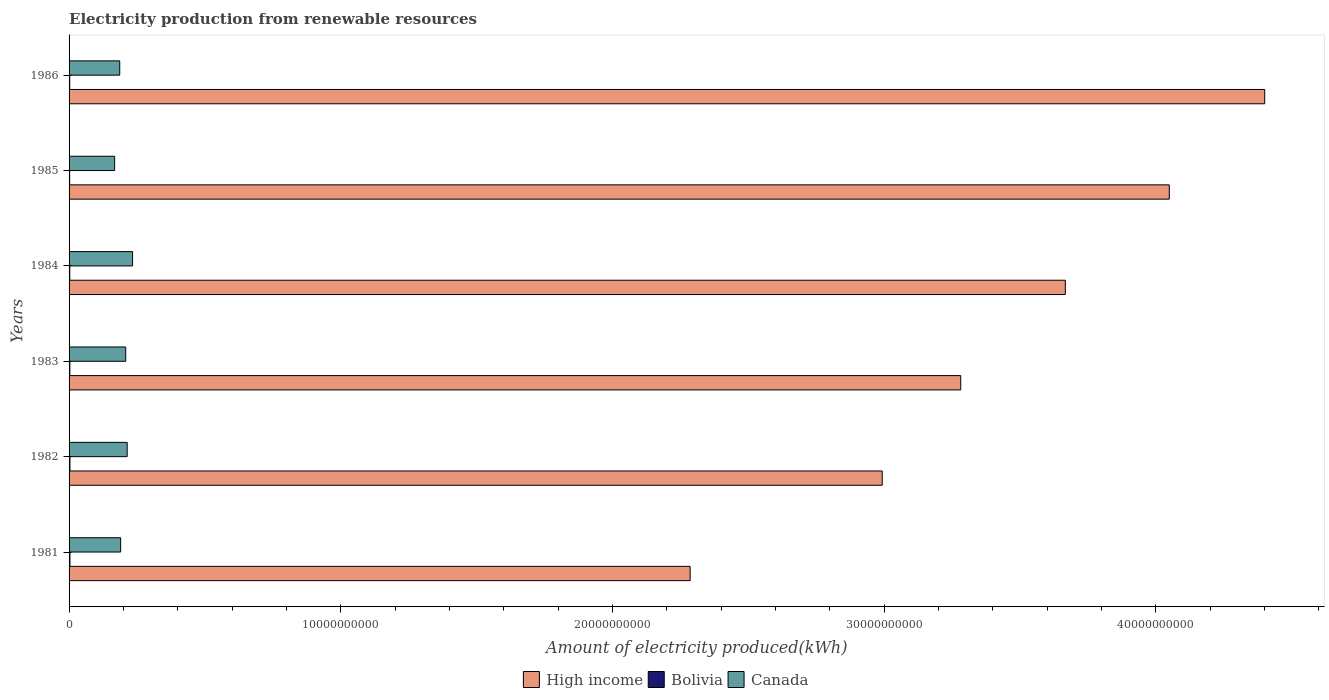How many bars are there on the 6th tick from the top?
Your response must be concise. 3. How many bars are there on the 1st tick from the bottom?
Provide a short and direct response. 3. What is the label of the 6th group of bars from the top?
Provide a succinct answer. 1981. In how many cases, is the number of bars for a given year not equal to the number of legend labels?
Ensure brevity in your answer.  0. What is the amount of electricity produced in Bolivia in 1983?
Your answer should be compact. 2.90e+07. Across all years, what is the maximum amount of electricity produced in Bolivia?
Provide a short and direct response. 3.20e+07. Across all years, what is the minimum amount of electricity produced in Canada?
Make the answer very short. 1.68e+09. What is the total amount of electricity produced in High income in the graph?
Make the answer very short. 2.07e+11. What is the difference between the amount of electricity produced in High income in 1981 and that in 1983?
Your response must be concise. -9.96e+09. What is the difference between the amount of electricity produced in Canada in 1985 and the amount of electricity produced in Bolivia in 1986?
Provide a succinct answer. 1.65e+09. What is the average amount of electricity produced in Bolivia per year?
Provide a short and direct response. 2.75e+07. In the year 1982, what is the difference between the amount of electricity produced in Bolivia and amount of electricity produced in High income?
Your response must be concise. -2.99e+1. What is the ratio of the amount of electricity produced in High income in 1981 to that in 1986?
Give a very brief answer. 0.52. Is the difference between the amount of electricity produced in Bolivia in 1982 and 1986 greater than the difference between the amount of electricity produced in High income in 1982 and 1986?
Give a very brief answer. Yes. What is the difference between the highest and the second highest amount of electricity produced in Canada?
Your response must be concise. 1.98e+08. What is the difference between the highest and the lowest amount of electricity produced in Canada?
Ensure brevity in your answer.  6.60e+08. What does the 2nd bar from the top in 1986 represents?
Provide a succinct answer. Bolivia. What does the 2nd bar from the bottom in 1982 represents?
Provide a short and direct response. Bolivia. How many bars are there?
Your answer should be very brief. 18. What is the difference between two consecutive major ticks on the X-axis?
Your answer should be compact. 1.00e+1. How are the legend labels stacked?
Keep it short and to the point. Horizontal. What is the title of the graph?
Offer a very short reply. Electricity production from renewable resources. What is the label or title of the X-axis?
Your answer should be very brief. Amount of electricity produced(kWh). What is the label or title of the Y-axis?
Keep it short and to the point. Years. What is the Amount of electricity produced(kWh) in High income in 1981?
Your response must be concise. 2.29e+1. What is the Amount of electricity produced(kWh) of Bolivia in 1981?
Make the answer very short. 3.20e+07. What is the Amount of electricity produced(kWh) in Canada in 1981?
Provide a short and direct response. 1.90e+09. What is the Amount of electricity produced(kWh) in High income in 1982?
Make the answer very short. 2.99e+1. What is the Amount of electricity produced(kWh) in Bolivia in 1982?
Your response must be concise. 3.20e+07. What is the Amount of electricity produced(kWh) of Canada in 1982?
Ensure brevity in your answer.  2.14e+09. What is the Amount of electricity produced(kWh) of High income in 1983?
Your answer should be very brief. 3.28e+1. What is the Amount of electricity produced(kWh) in Bolivia in 1983?
Offer a terse response. 2.90e+07. What is the Amount of electricity produced(kWh) of Canada in 1983?
Your answer should be compact. 2.08e+09. What is the Amount of electricity produced(kWh) of High income in 1984?
Ensure brevity in your answer.  3.67e+1. What is the Amount of electricity produced(kWh) of Bolivia in 1984?
Your answer should be very brief. 2.60e+07. What is the Amount of electricity produced(kWh) in Canada in 1984?
Your response must be concise. 2.34e+09. What is the Amount of electricity produced(kWh) of High income in 1985?
Offer a terse response. 4.05e+1. What is the Amount of electricity produced(kWh) in Bolivia in 1985?
Your answer should be very brief. 2.20e+07. What is the Amount of electricity produced(kWh) of Canada in 1985?
Ensure brevity in your answer.  1.68e+09. What is the Amount of electricity produced(kWh) of High income in 1986?
Give a very brief answer. 4.40e+1. What is the Amount of electricity produced(kWh) of Bolivia in 1986?
Keep it short and to the point. 2.40e+07. What is the Amount of electricity produced(kWh) of Canada in 1986?
Your response must be concise. 1.86e+09. Across all years, what is the maximum Amount of electricity produced(kWh) of High income?
Ensure brevity in your answer.  4.40e+1. Across all years, what is the maximum Amount of electricity produced(kWh) of Bolivia?
Your response must be concise. 3.20e+07. Across all years, what is the maximum Amount of electricity produced(kWh) in Canada?
Offer a very short reply. 2.34e+09. Across all years, what is the minimum Amount of electricity produced(kWh) of High income?
Offer a very short reply. 2.29e+1. Across all years, what is the minimum Amount of electricity produced(kWh) of Bolivia?
Ensure brevity in your answer.  2.20e+07. Across all years, what is the minimum Amount of electricity produced(kWh) of Canada?
Make the answer very short. 1.68e+09. What is the total Amount of electricity produced(kWh) in High income in the graph?
Your answer should be very brief. 2.07e+11. What is the total Amount of electricity produced(kWh) of Bolivia in the graph?
Your answer should be very brief. 1.65e+08. What is the total Amount of electricity produced(kWh) of Canada in the graph?
Provide a succinct answer. 1.20e+1. What is the difference between the Amount of electricity produced(kWh) of High income in 1981 and that in 1982?
Offer a very short reply. -7.07e+09. What is the difference between the Amount of electricity produced(kWh) of Bolivia in 1981 and that in 1982?
Offer a very short reply. 0. What is the difference between the Amount of electricity produced(kWh) of Canada in 1981 and that in 1982?
Make the answer very short. -2.41e+08. What is the difference between the Amount of electricity produced(kWh) in High income in 1981 and that in 1983?
Provide a succinct answer. -9.96e+09. What is the difference between the Amount of electricity produced(kWh) in Canada in 1981 and that in 1983?
Your answer should be very brief. -1.87e+08. What is the difference between the Amount of electricity produced(kWh) of High income in 1981 and that in 1984?
Provide a succinct answer. -1.38e+1. What is the difference between the Amount of electricity produced(kWh) of Canada in 1981 and that in 1984?
Ensure brevity in your answer.  -4.39e+08. What is the difference between the Amount of electricity produced(kWh) in High income in 1981 and that in 1985?
Offer a very short reply. -1.76e+1. What is the difference between the Amount of electricity produced(kWh) in Canada in 1981 and that in 1985?
Provide a short and direct response. 2.21e+08. What is the difference between the Amount of electricity produced(kWh) of High income in 1981 and that in 1986?
Offer a very short reply. -2.11e+1. What is the difference between the Amount of electricity produced(kWh) of Bolivia in 1981 and that in 1986?
Provide a succinct answer. 8.00e+06. What is the difference between the Amount of electricity produced(kWh) of Canada in 1981 and that in 1986?
Provide a succinct answer. 3.30e+07. What is the difference between the Amount of electricity produced(kWh) in High income in 1982 and that in 1983?
Your answer should be very brief. -2.89e+09. What is the difference between the Amount of electricity produced(kWh) of Canada in 1982 and that in 1983?
Your response must be concise. 5.40e+07. What is the difference between the Amount of electricity produced(kWh) in High income in 1982 and that in 1984?
Offer a very short reply. -6.74e+09. What is the difference between the Amount of electricity produced(kWh) of Bolivia in 1982 and that in 1984?
Your answer should be compact. 6.00e+06. What is the difference between the Amount of electricity produced(kWh) of Canada in 1982 and that in 1984?
Your response must be concise. -1.98e+08. What is the difference between the Amount of electricity produced(kWh) in High income in 1982 and that in 1985?
Your answer should be compact. -1.06e+1. What is the difference between the Amount of electricity produced(kWh) in Canada in 1982 and that in 1985?
Your response must be concise. 4.62e+08. What is the difference between the Amount of electricity produced(kWh) in High income in 1982 and that in 1986?
Your answer should be compact. -1.41e+1. What is the difference between the Amount of electricity produced(kWh) in Bolivia in 1982 and that in 1986?
Give a very brief answer. 8.00e+06. What is the difference between the Amount of electricity produced(kWh) in Canada in 1982 and that in 1986?
Offer a terse response. 2.74e+08. What is the difference between the Amount of electricity produced(kWh) in High income in 1983 and that in 1984?
Offer a very short reply. -3.85e+09. What is the difference between the Amount of electricity produced(kWh) of Bolivia in 1983 and that in 1984?
Keep it short and to the point. 3.00e+06. What is the difference between the Amount of electricity produced(kWh) of Canada in 1983 and that in 1984?
Ensure brevity in your answer.  -2.52e+08. What is the difference between the Amount of electricity produced(kWh) in High income in 1983 and that in 1985?
Your answer should be compact. -7.68e+09. What is the difference between the Amount of electricity produced(kWh) in Bolivia in 1983 and that in 1985?
Your answer should be very brief. 7.00e+06. What is the difference between the Amount of electricity produced(kWh) in Canada in 1983 and that in 1985?
Provide a succinct answer. 4.08e+08. What is the difference between the Amount of electricity produced(kWh) in High income in 1983 and that in 1986?
Your answer should be very brief. -1.12e+1. What is the difference between the Amount of electricity produced(kWh) in Canada in 1983 and that in 1986?
Provide a short and direct response. 2.20e+08. What is the difference between the Amount of electricity produced(kWh) of High income in 1984 and that in 1985?
Provide a short and direct response. -3.83e+09. What is the difference between the Amount of electricity produced(kWh) of Bolivia in 1984 and that in 1985?
Your answer should be very brief. 4.00e+06. What is the difference between the Amount of electricity produced(kWh) of Canada in 1984 and that in 1985?
Your answer should be compact. 6.60e+08. What is the difference between the Amount of electricity produced(kWh) in High income in 1984 and that in 1986?
Make the answer very short. -7.34e+09. What is the difference between the Amount of electricity produced(kWh) of Canada in 1984 and that in 1986?
Give a very brief answer. 4.72e+08. What is the difference between the Amount of electricity produced(kWh) in High income in 1985 and that in 1986?
Provide a succinct answer. -3.51e+09. What is the difference between the Amount of electricity produced(kWh) of Canada in 1985 and that in 1986?
Your response must be concise. -1.88e+08. What is the difference between the Amount of electricity produced(kWh) in High income in 1981 and the Amount of electricity produced(kWh) in Bolivia in 1982?
Make the answer very short. 2.28e+1. What is the difference between the Amount of electricity produced(kWh) in High income in 1981 and the Amount of electricity produced(kWh) in Canada in 1982?
Give a very brief answer. 2.07e+1. What is the difference between the Amount of electricity produced(kWh) of Bolivia in 1981 and the Amount of electricity produced(kWh) of Canada in 1982?
Make the answer very short. -2.11e+09. What is the difference between the Amount of electricity produced(kWh) of High income in 1981 and the Amount of electricity produced(kWh) of Bolivia in 1983?
Provide a succinct answer. 2.28e+1. What is the difference between the Amount of electricity produced(kWh) of High income in 1981 and the Amount of electricity produced(kWh) of Canada in 1983?
Offer a terse response. 2.08e+1. What is the difference between the Amount of electricity produced(kWh) in Bolivia in 1981 and the Amount of electricity produced(kWh) in Canada in 1983?
Keep it short and to the point. -2.05e+09. What is the difference between the Amount of electricity produced(kWh) in High income in 1981 and the Amount of electricity produced(kWh) in Bolivia in 1984?
Your response must be concise. 2.28e+1. What is the difference between the Amount of electricity produced(kWh) in High income in 1981 and the Amount of electricity produced(kWh) in Canada in 1984?
Provide a short and direct response. 2.05e+1. What is the difference between the Amount of electricity produced(kWh) in Bolivia in 1981 and the Amount of electricity produced(kWh) in Canada in 1984?
Give a very brief answer. -2.30e+09. What is the difference between the Amount of electricity produced(kWh) of High income in 1981 and the Amount of electricity produced(kWh) of Bolivia in 1985?
Provide a short and direct response. 2.28e+1. What is the difference between the Amount of electricity produced(kWh) in High income in 1981 and the Amount of electricity produced(kWh) in Canada in 1985?
Give a very brief answer. 2.12e+1. What is the difference between the Amount of electricity produced(kWh) in Bolivia in 1981 and the Amount of electricity produced(kWh) in Canada in 1985?
Keep it short and to the point. -1.64e+09. What is the difference between the Amount of electricity produced(kWh) in High income in 1981 and the Amount of electricity produced(kWh) in Bolivia in 1986?
Provide a short and direct response. 2.28e+1. What is the difference between the Amount of electricity produced(kWh) in High income in 1981 and the Amount of electricity produced(kWh) in Canada in 1986?
Provide a short and direct response. 2.10e+1. What is the difference between the Amount of electricity produced(kWh) of Bolivia in 1981 and the Amount of electricity produced(kWh) of Canada in 1986?
Your answer should be compact. -1.83e+09. What is the difference between the Amount of electricity produced(kWh) in High income in 1982 and the Amount of electricity produced(kWh) in Bolivia in 1983?
Your answer should be compact. 2.99e+1. What is the difference between the Amount of electricity produced(kWh) of High income in 1982 and the Amount of electricity produced(kWh) of Canada in 1983?
Your answer should be compact. 2.78e+1. What is the difference between the Amount of electricity produced(kWh) of Bolivia in 1982 and the Amount of electricity produced(kWh) of Canada in 1983?
Give a very brief answer. -2.05e+09. What is the difference between the Amount of electricity produced(kWh) of High income in 1982 and the Amount of electricity produced(kWh) of Bolivia in 1984?
Provide a succinct answer. 2.99e+1. What is the difference between the Amount of electricity produced(kWh) in High income in 1982 and the Amount of electricity produced(kWh) in Canada in 1984?
Make the answer very short. 2.76e+1. What is the difference between the Amount of electricity produced(kWh) in Bolivia in 1982 and the Amount of electricity produced(kWh) in Canada in 1984?
Your response must be concise. -2.30e+09. What is the difference between the Amount of electricity produced(kWh) of High income in 1982 and the Amount of electricity produced(kWh) of Bolivia in 1985?
Keep it short and to the point. 2.99e+1. What is the difference between the Amount of electricity produced(kWh) of High income in 1982 and the Amount of electricity produced(kWh) of Canada in 1985?
Make the answer very short. 2.83e+1. What is the difference between the Amount of electricity produced(kWh) in Bolivia in 1982 and the Amount of electricity produced(kWh) in Canada in 1985?
Offer a very short reply. -1.64e+09. What is the difference between the Amount of electricity produced(kWh) in High income in 1982 and the Amount of electricity produced(kWh) in Bolivia in 1986?
Keep it short and to the point. 2.99e+1. What is the difference between the Amount of electricity produced(kWh) of High income in 1982 and the Amount of electricity produced(kWh) of Canada in 1986?
Your answer should be compact. 2.81e+1. What is the difference between the Amount of electricity produced(kWh) of Bolivia in 1982 and the Amount of electricity produced(kWh) of Canada in 1986?
Provide a short and direct response. -1.83e+09. What is the difference between the Amount of electricity produced(kWh) of High income in 1983 and the Amount of electricity produced(kWh) of Bolivia in 1984?
Keep it short and to the point. 3.28e+1. What is the difference between the Amount of electricity produced(kWh) in High income in 1983 and the Amount of electricity produced(kWh) in Canada in 1984?
Offer a terse response. 3.05e+1. What is the difference between the Amount of electricity produced(kWh) in Bolivia in 1983 and the Amount of electricity produced(kWh) in Canada in 1984?
Make the answer very short. -2.31e+09. What is the difference between the Amount of electricity produced(kWh) of High income in 1983 and the Amount of electricity produced(kWh) of Bolivia in 1985?
Offer a very short reply. 3.28e+1. What is the difference between the Amount of electricity produced(kWh) in High income in 1983 and the Amount of electricity produced(kWh) in Canada in 1985?
Your response must be concise. 3.11e+1. What is the difference between the Amount of electricity produced(kWh) of Bolivia in 1983 and the Amount of electricity produced(kWh) of Canada in 1985?
Provide a succinct answer. -1.65e+09. What is the difference between the Amount of electricity produced(kWh) of High income in 1983 and the Amount of electricity produced(kWh) of Bolivia in 1986?
Make the answer very short. 3.28e+1. What is the difference between the Amount of electricity produced(kWh) in High income in 1983 and the Amount of electricity produced(kWh) in Canada in 1986?
Your response must be concise. 3.10e+1. What is the difference between the Amount of electricity produced(kWh) in Bolivia in 1983 and the Amount of electricity produced(kWh) in Canada in 1986?
Your answer should be compact. -1.84e+09. What is the difference between the Amount of electricity produced(kWh) of High income in 1984 and the Amount of electricity produced(kWh) of Bolivia in 1985?
Your response must be concise. 3.66e+1. What is the difference between the Amount of electricity produced(kWh) of High income in 1984 and the Amount of electricity produced(kWh) of Canada in 1985?
Your answer should be very brief. 3.50e+1. What is the difference between the Amount of electricity produced(kWh) in Bolivia in 1984 and the Amount of electricity produced(kWh) in Canada in 1985?
Ensure brevity in your answer.  -1.65e+09. What is the difference between the Amount of electricity produced(kWh) of High income in 1984 and the Amount of electricity produced(kWh) of Bolivia in 1986?
Your answer should be very brief. 3.66e+1. What is the difference between the Amount of electricity produced(kWh) of High income in 1984 and the Amount of electricity produced(kWh) of Canada in 1986?
Offer a very short reply. 3.48e+1. What is the difference between the Amount of electricity produced(kWh) in Bolivia in 1984 and the Amount of electricity produced(kWh) in Canada in 1986?
Offer a very short reply. -1.84e+09. What is the difference between the Amount of electricity produced(kWh) of High income in 1985 and the Amount of electricity produced(kWh) of Bolivia in 1986?
Your answer should be compact. 4.05e+1. What is the difference between the Amount of electricity produced(kWh) in High income in 1985 and the Amount of electricity produced(kWh) in Canada in 1986?
Keep it short and to the point. 3.86e+1. What is the difference between the Amount of electricity produced(kWh) in Bolivia in 1985 and the Amount of electricity produced(kWh) in Canada in 1986?
Your answer should be compact. -1.84e+09. What is the average Amount of electricity produced(kWh) in High income per year?
Ensure brevity in your answer.  3.45e+1. What is the average Amount of electricity produced(kWh) of Bolivia per year?
Make the answer very short. 2.75e+07. What is the average Amount of electricity produced(kWh) in Canada per year?
Provide a succinct answer. 2.00e+09. In the year 1981, what is the difference between the Amount of electricity produced(kWh) of High income and Amount of electricity produced(kWh) of Bolivia?
Offer a very short reply. 2.28e+1. In the year 1981, what is the difference between the Amount of electricity produced(kWh) of High income and Amount of electricity produced(kWh) of Canada?
Provide a succinct answer. 2.10e+1. In the year 1981, what is the difference between the Amount of electricity produced(kWh) of Bolivia and Amount of electricity produced(kWh) of Canada?
Keep it short and to the point. -1.87e+09. In the year 1982, what is the difference between the Amount of electricity produced(kWh) in High income and Amount of electricity produced(kWh) in Bolivia?
Provide a succinct answer. 2.99e+1. In the year 1982, what is the difference between the Amount of electricity produced(kWh) in High income and Amount of electricity produced(kWh) in Canada?
Offer a terse response. 2.78e+1. In the year 1982, what is the difference between the Amount of electricity produced(kWh) in Bolivia and Amount of electricity produced(kWh) in Canada?
Give a very brief answer. -2.11e+09. In the year 1983, what is the difference between the Amount of electricity produced(kWh) in High income and Amount of electricity produced(kWh) in Bolivia?
Your answer should be very brief. 3.28e+1. In the year 1983, what is the difference between the Amount of electricity produced(kWh) in High income and Amount of electricity produced(kWh) in Canada?
Ensure brevity in your answer.  3.07e+1. In the year 1983, what is the difference between the Amount of electricity produced(kWh) in Bolivia and Amount of electricity produced(kWh) in Canada?
Your answer should be compact. -2.06e+09. In the year 1984, what is the difference between the Amount of electricity produced(kWh) of High income and Amount of electricity produced(kWh) of Bolivia?
Ensure brevity in your answer.  3.66e+1. In the year 1984, what is the difference between the Amount of electricity produced(kWh) of High income and Amount of electricity produced(kWh) of Canada?
Make the answer very short. 3.43e+1. In the year 1984, what is the difference between the Amount of electricity produced(kWh) of Bolivia and Amount of electricity produced(kWh) of Canada?
Offer a terse response. -2.31e+09. In the year 1985, what is the difference between the Amount of electricity produced(kWh) in High income and Amount of electricity produced(kWh) in Bolivia?
Your response must be concise. 4.05e+1. In the year 1985, what is the difference between the Amount of electricity produced(kWh) of High income and Amount of electricity produced(kWh) of Canada?
Provide a short and direct response. 3.88e+1. In the year 1985, what is the difference between the Amount of electricity produced(kWh) in Bolivia and Amount of electricity produced(kWh) in Canada?
Make the answer very short. -1.66e+09. In the year 1986, what is the difference between the Amount of electricity produced(kWh) in High income and Amount of electricity produced(kWh) in Bolivia?
Provide a short and direct response. 4.40e+1. In the year 1986, what is the difference between the Amount of electricity produced(kWh) of High income and Amount of electricity produced(kWh) of Canada?
Offer a very short reply. 4.21e+1. In the year 1986, what is the difference between the Amount of electricity produced(kWh) in Bolivia and Amount of electricity produced(kWh) in Canada?
Keep it short and to the point. -1.84e+09. What is the ratio of the Amount of electricity produced(kWh) in High income in 1981 to that in 1982?
Provide a short and direct response. 0.76. What is the ratio of the Amount of electricity produced(kWh) of Canada in 1981 to that in 1982?
Give a very brief answer. 0.89. What is the ratio of the Amount of electricity produced(kWh) in High income in 1981 to that in 1983?
Your answer should be very brief. 0.7. What is the ratio of the Amount of electricity produced(kWh) of Bolivia in 1981 to that in 1983?
Your response must be concise. 1.1. What is the ratio of the Amount of electricity produced(kWh) in Canada in 1981 to that in 1983?
Keep it short and to the point. 0.91. What is the ratio of the Amount of electricity produced(kWh) of High income in 1981 to that in 1984?
Ensure brevity in your answer.  0.62. What is the ratio of the Amount of electricity produced(kWh) in Bolivia in 1981 to that in 1984?
Make the answer very short. 1.23. What is the ratio of the Amount of electricity produced(kWh) of Canada in 1981 to that in 1984?
Your answer should be compact. 0.81. What is the ratio of the Amount of electricity produced(kWh) of High income in 1981 to that in 1985?
Provide a short and direct response. 0.56. What is the ratio of the Amount of electricity produced(kWh) of Bolivia in 1981 to that in 1985?
Provide a short and direct response. 1.45. What is the ratio of the Amount of electricity produced(kWh) of Canada in 1981 to that in 1985?
Provide a succinct answer. 1.13. What is the ratio of the Amount of electricity produced(kWh) in High income in 1981 to that in 1986?
Make the answer very short. 0.52. What is the ratio of the Amount of electricity produced(kWh) of Bolivia in 1981 to that in 1986?
Offer a very short reply. 1.33. What is the ratio of the Amount of electricity produced(kWh) of Canada in 1981 to that in 1986?
Keep it short and to the point. 1.02. What is the ratio of the Amount of electricity produced(kWh) of High income in 1982 to that in 1983?
Offer a very short reply. 0.91. What is the ratio of the Amount of electricity produced(kWh) in Bolivia in 1982 to that in 1983?
Offer a very short reply. 1.1. What is the ratio of the Amount of electricity produced(kWh) in Canada in 1982 to that in 1983?
Provide a short and direct response. 1.03. What is the ratio of the Amount of electricity produced(kWh) of High income in 1982 to that in 1984?
Your answer should be very brief. 0.82. What is the ratio of the Amount of electricity produced(kWh) of Bolivia in 1982 to that in 1984?
Offer a very short reply. 1.23. What is the ratio of the Amount of electricity produced(kWh) in Canada in 1982 to that in 1984?
Ensure brevity in your answer.  0.92. What is the ratio of the Amount of electricity produced(kWh) of High income in 1982 to that in 1985?
Keep it short and to the point. 0.74. What is the ratio of the Amount of electricity produced(kWh) in Bolivia in 1982 to that in 1985?
Your response must be concise. 1.45. What is the ratio of the Amount of electricity produced(kWh) in Canada in 1982 to that in 1985?
Your response must be concise. 1.28. What is the ratio of the Amount of electricity produced(kWh) in High income in 1982 to that in 1986?
Offer a very short reply. 0.68. What is the ratio of the Amount of electricity produced(kWh) in Canada in 1982 to that in 1986?
Your answer should be compact. 1.15. What is the ratio of the Amount of electricity produced(kWh) in High income in 1983 to that in 1984?
Your response must be concise. 0.9. What is the ratio of the Amount of electricity produced(kWh) of Bolivia in 1983 to that in 1984?
Your answer should be compact. 1.12. What is the ratio of the Amount of electricity produced(kWh) in Canada in 1983 to that in 1984?
Make the answer very short. 0.89. What is the ratio of the Amount of electricity produced(kWh) in High income in 1983 to that in 1985?
Offer a very short reply. 0.81. What is the ratio of the Amount of electricity produced(kWh) of Bolivia in 1983 to that in 1985?
Give a very brief answer. 1.32. What is the ratio of the Amount of electricity produced(kWh) of Canada in 1983 to that in 1985?
Ensure brevity in your answer.  1.24. What is the ratio of the Amount of electricity produced(kWh) in High income in 1983 to that in 1986?
Give a very brief answer. 0.75. What is the ratio of the Amount of electricity produced(kWh) of Bolivia in 1983 to that in 1986?
Ensure brevity in your answer.  1.21. What is the ratio of the Amount of electricity produced(kWh) in Canada in 1983 to that in 1986?
Offer a very short reply. 1.12. What is the ratio of the Amount of electricity produced(kWh) in High income in 1984 to that in 1985?
Provide a short and direct response. 0.91. What is the ratio of the Amount of electricity produced(kWh) in Bolivia in 1984 to that in 1985?
Your answer should be compact. 1.18. What is the ratio of the Amount of electricity produced(kWh) in Canada in 1984 to that in 1985?
Provide a succinct answer. 1.39. What is the ratio of the Amount of electricity produced(kWh) in Bolivia in 1984 to that in 1986?
Make the answer very short. 1.08. What is the ratio of the Amount of electricity produced(kWh) in Canada in 1984 to that in 1986?
Offer a very short reply. 1.25. What is the ratio of the Amount of electricity produced(kWh) in High income in 1985 to that in 1986?
Provide a short and direct response. 0.92. What is the ratio of the Amount of electricity produced(kWh) in Bolivia in 1985 to that in 1986?
Give a very brief answer. 0.92. What is the ratio of the Amount of electricity produced(kWh) in Canada in 1985 to that in 1986?
Keep it short and to the point. 0.9. What is the difference between the highest and the second highest Amount of electricity produced(kWh) of High income?
Provide a succinct answer. 3.51e+09. What is the difference between the highest and the second highest Amount of electricity produced(kWh) of Bolivia?
Provide a short and direct response. 0. What is the difference between the highest and the second highest Amount of electricity produced(kWh) of Canada?
Make the answer very short. 1.98e+08. What is the difference between the highest and the lowest Amount of electricity produced(kWh) in High income?
Offer a very short reply. 2.11e+1. What is the difference between the highest and the lowest Amount of electricity produced(kWh) in Canada?
Ensure brevity in your answer.  6.60e+08. 